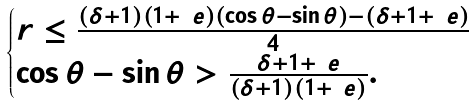Convert formula to latex. <formula><loc_0><loc_0><loc_500><loc_500>\begin{cases} r \leq \frac { ( \delta + 1 ) ( 1 + \ e ) ( \cos \theta - \sin \theta ) - ( \delta + 1 + \ e ) } { 4 } \\ \cos \theta - \sin \theta > \frac { \delta + 1 + \ e } { ( \delta + 1 ) ( 1 + \ e ) } . \end{cases}</formula> 